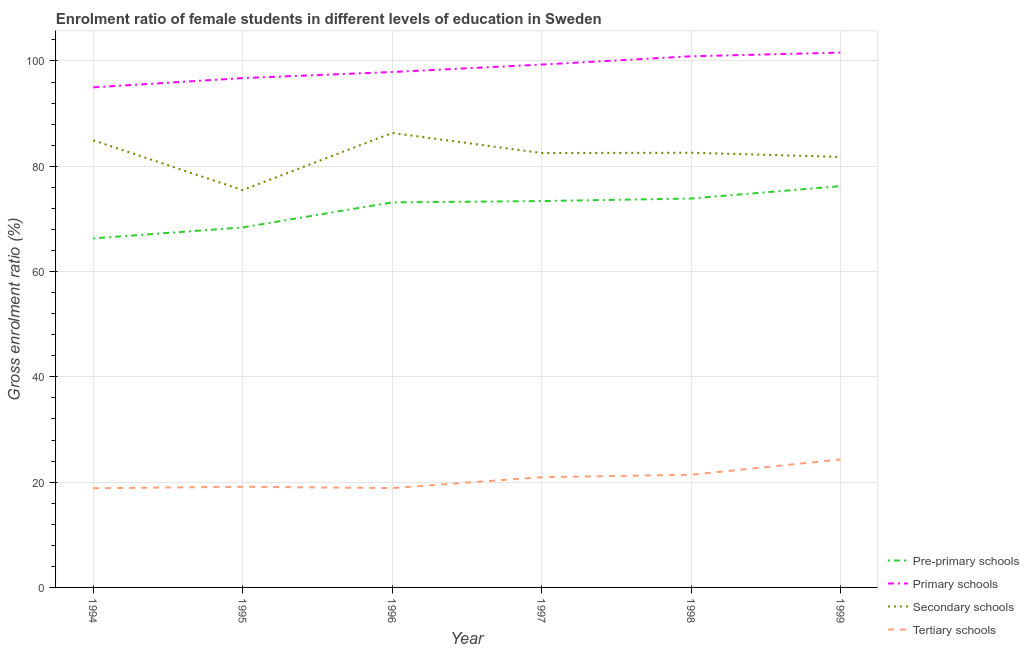What is the gross enrolment ratio(male) in primary schools in 1998?
Provide a short and direct response. 100.89. Across all years, what is the maximum gross enrolment ratio(male) in pre-primary schools?
Your answer should be compact. 76.23. Across all years, what is the minimum gross enrolment ratio(male) in tertiary schools?
Provide a short and direct response. 18.84. In which year was the gross enrolment ratio(male) in tertiary schools maximum?
Make the answer very short. 1999. What is the total gross enrolment ratio(male) in tertiary schools in the graph?
Provide a succinct answer. 123.48. What is the difference between the gross enrolment ratio(male) in primary schools in 1994 and that in 1997?
Your response must be concise. -4.33. What is the difference between the gross enrolment ratio(male) in primary schools in 1996 and the gross enrolment ratio(male) in tertiary schools in 1994?
Offer a very short reply. 79.06. What is the average gross enrolment ratio(male) in primary schools per year?
Offer a very short reply. 98.58. In the year 1999, what is the difference between the gross enrolment ratio(male) in primary schools and gross enrolment ratio(male) in tertiary schools?
Provide a short and direct response. 77.29. In how many years, is the gross enrolment ratio(male) in secondary schools greater than 68 %?
Your response must be concise. 6. What is the ratio of the gross enrolment ratio(male) in pre-primary schools in 1995 to that in 1996?
Ensure brevity in your answer.  0.93. Is the difference between the gross enrolment ratio(male) in tertiary schools in 1995 and 1998 greater than the difference between the gross enrolment ratio(male) in pre-primary schools in 1995 and 1998?
Your answer should be compact. Yes. What is the difference between the highest and the second highest gross enrolment ratio(male) in tertiary schools?
Offer a terse response. 2.9. What is the difference between the highest and the lowest gross enrolment ratio(male) in tertiary schools?
Your response must be concise. 5.46. In how many years, is the gross enrolment ratio(male) in secondary schools greater than the average gross enrolment ratio(male) in secondary schools taken over all years?
Offer a very short reply. 4. Is it the case that in every year, the sum of the gross enrolment ratio(male) in pre-primary schools and gross enrolment ratio(male) in primary schools is greater than the gross enrolment ratio(male) in secondary schools?
Your answer should be compact. Yes. Does the gross enrolment ratio(male) in primary schools monotonically increase over the years?
Your answer should be very brief. Yes. Is the gross enrolment ratio(male) in pre-primary schools strictly greater than the gross enrolment ratio(male) in secondary schools over the years?
Your answer should be compact. No. How many lines are there?
Give a very brief answer. 4. Are the values on the major ticks of Y-axis written in scientific E-notation?
Make the answer very short. No. Where does the legend appear in the graph?
Offer a terse response. Bottom right. What is the title of the graph?
Your answer should be compact. Enrolment ratio of female students in different levels of education in Sweden. Does "Manufacturing" appear as one of the legend labels in the graph?
Offer a terse response. No. What is the Gross enrolment ratio (%) in Pre-primary schools in 1994?
Your response must be concise. 66.3. What is the Gross enrolment ratio (%) in Primary schools in 1994?
Your answer should be compact. 94.99. What is the Gross enrolment ratio (%) of Secondary schools in 1994?
Keep it short and to the point. 84.93. What is the Gross enrolment ratio (%) of Tertiary schools in 1994?
Keep it short and to the point. 18.84. What is the Gross enrolment ratio (%) of Pre-primary schools in 1995?
Your response must be concise. 68.39. What is the Gross enrolment ratio (%) of Primary schools in 1995?
Offer a terse response. 96.75. What is the Gross enrolment ratio (%) in Secondary schools in 1995?
Make the answer very short. 75.47. What is the Gross enrolment ratio (%) in Tertiary schools in 1995?
Offer a very short reply. 19.12. What is the Gross enrolment ratio (%) in Pre-primary schools in 1996?
Offer a terse response. 73.14. What is the Gross enrolment ratio (%) in Primary schools in 1996?
Give a very brief answer. 97.91. What is the Gross enrolment ratio (%) in Secondary schools in 1996?
Provide a succinct answer. 86.33. What is the Gross enrolment ratio (%) of Tertiary schools in 1996?
Provide a short and direct response. 18.87. What is the Gross enrolment ratio (%) in Pre-primary schools in 1997?
Provide a succinct answer. 73.39. What is the Gross enrolment ratio (%) of Primary schools in 1997?
Your response must be concise. 99.32. What is the Gross enrolment ratio (%) of Secondary schools in 1997?
Offer a very short reply. 82.52. What is the Gross enrolment ratio (%) of Tertiary schools in 1997?
Offer a very short reply. 20.93. What is the Gross enrolment ratio (%) of Pre-primary schools in 1998?
Your response must be concise. 73.87. What is the Gross enrolment ratio (%) of Primary schools in 1998?
Make the answer very short. 100.89. What is the Gross enrolment ratio (%) in Secondary schools in 1998?
Make the answer very short. 82.57. What is the Gross enrolment ratio (%) of Tertiary schools in 1998?
Provide a succinct answer. 21.41. What is the Gross enrolment ratio (%) in Pre-primary schools in 1999?
Your answer should be compact. 76.23. What is the Gross enrolment ratio (%) in Primary schools in 1999?
Your response must be concise. 101.59. What is the Gross enrolment ratio (%) of Secondary schools in 1999?
Your answer should be very brief. 81.77. What is the Gross enrolment ratio (%) of Tertiary schools in 1999?
Your response must be concise. 24.31. Across all years, what is the maximum Gross enrolment ratio (%) in Pre-primary schools?
Make the answer very short. 76.23. Across all years, what is the maximum Gross enrolment ratio (%) of Primary schools?
Offer a very short reply. 101.59. Across all years, what is the maximum Gross enrolment ratio (%) of Secondary schools?
Offer a terse response. 86.33. Across all years, what is the maximum Gross enrolment ratio (%) of Tertiary schools?
Offer a terse response. 24.31. Across all years, what is the minimum Gross enrolment ratio (%) in Pre-primary schools?
Give a very brief answer. 66.3. Across all years, what is the minimum Gross enrolment ratio (%) of Primary schools?
Your response must be concise. 94.99. Across all years, what is the minimum Gross enrolment ratio (%) of Secondary schools?
Provide a succinct answer. 75.47. Across all years, what is the minimum Gross enrolment ratio (%) of Tertiary schools?
Your answer should be very brief. 18.84. What is the total Gross enrolment ratio (%) of Pre-primary schools in the graph?
Give a very brief answer. 431.32. What is the total Gross enrolment ratio (%) of Primary schools in the graph?
Keep it short and to the point. 591.45. What is the total Gross enrolment ratio (%) of Secondary schools in the graph?
Your response must be concise. 493.59. What is the total Gross enrolment ratio (%) in Tertiary schools in the graph?
Provide a succinct answer. 123.48. What is the difference between the Gross enrolment ratio (%) of Pre-primary schools in 1994 and that in 1995?
Give a very brief answer. -2.09. What is the difference between the Gross enrolment ratio (%) of Primary schools in 1994 and that in 1995?
Your answer should be compact. -1.76. What is the difference between the Gross enrolment ratio (%) in Secondary schools in 1994 and that in 1995?
Ensure brevity in your answer.  9.46. What is the difference between the Gross enrolment ratio (%) in Tertiary schools in 1994 and that in 1995?
Give a very brief answer. -0.28. What is the difference between the Gross enrolment ratio (%) in Pre-primary schools in 1994 and that in 1996?
Your answer should be compact. -6.84. What is the difference between the Gross enrolment ratio (%) in Primary schools in 1994 and that in 1996?
Offer a terse response. -2.92. What is the difference between the Gross enrolment ratio (%) in Secondary schools in 1994 and that in 1996?
Ensure brevity in your answer.  -1.4. What is the difference between the Gross enrolment ratio (%) in Tertiary schools in 1994 and that in 1996?
Offer a very short reply. -0.03. What is the difference between the Gross enrolment ratio (%) of Pre-primary schools in 1994 and that in 1997?
Ensure brevity in your answer.  -7.09. What is the difference between the Gross enrolment ratio (%) in Primary schools in 1994 and that in 1997?
Offer a terse response. -4.33. What is the difference between the Gross enrolment ratio (%) in Secondary schools in 1994 and that in 1997?
Give a very brief answer. 2.41. What is the difference between the Gross enrolment ratio (%) of Tertiary schools in 1994 and that in 1997?
Keep it short and to the point. -2.09. What is the difference between the Gross enrolment ratio (%) in Pre-primary schools in 1994 and that in 1998?
Your answer should be compact. -7.58. What is the difference between the Gross enrolment ratio (%) of Primary schools in 1994 and that in 1998?
Keep it short and to the point. -5.9. What is the difference between the Gross enrolment ratio (%) of Secondary schools in 1994 and that in 1998?
Your response must be concise. 2.36. What is the difference between the Gross enrolment ratio (%) of Tertiary schools in 1994 and that in 1998?
Offer a very short reply. -2.56. What is the difference between the Gross enrolment ratio (%) in Pre-primary schools in 1994 and that in 1999?
Make the answer very short. -9.94. What is the difference between the Gross enrolment ratio (%) of Primary schools in 1994 and that in 1999?
Your answer should be very brief. -6.6. What is the difference between the Gross enrolment ratio (%) of Secondary schools in 1994 and that in 1999?
Offer a very short reply. 3.15. What is the difference between the Gross enrolment ratio (%) in Tertiary schools in 1994 and that in 1999?
Make the answer very short. -5.46. What is the difference between the Gross enrolment ratio (%) in Pre-primary schools in 1995 and that in 1996?
Your answer should be very brief. -4.76. What is the difference between the Gross enrolment ratio (%) of Primary schools in 1995 and that in 1996?
Provide a short and direct response. -1.16. What is the difference between the Gross enrolment ratio (%) in Secondary schools in 1995 and that in 1996?
Give a very brief answer. -10.86. What is the difference between the Gross enrolment ratio (%) of Tertiary schools in 1995 and that in 1996?
Keep it short and to the point. 0.24. What is the difference between the Gross enrolment ratio (%) of Pre-primary schools in 1995 and that in 1997?
Keep it short and to the point. -5. What is the difference between the Gross enrolment ratio (%) of Primary schools in 1995 and that in 1997?
Offer a terse response. -2.57. What is the difference between the Gross enrolment ratio (%) in Secondary schools in 1995 and that in 1997?
Offer a very short reply. -7.04. What is the difference between the Gross enrolment ratio (%) in Tertiary schools in 1995 and that in 1997?
Offer a very short reply. -1.81. What is the difference between the Gross enrolment ratio (%) in Pre-primary schools in 1995 and that in 1998?
Make the answer very short. -5.49. What is the difference between the Gross enrolment ratio (%) in Primary schools in 1995 and that in 1998?
Provide a succinct answer. -4.14. What is the difference between the Gross enrolment ratio (%) of Secondary schools in 1995 and that in 1998?
Your response must be concise. -7.1. What is the difference between the Gross enrolment ratio (%) of Tertiary schools in 1995 and that in 1998?
Give a very brief answer. -2.29. What is the difference between the Gross enrolment ratio (%) of Pre-primary schools in 1995 and that in 1999?
Your answer should be very brief. -7.85. What is the difference between the Gross enrolment ratio (%) in Primary schools in 1995 and that in 1999?
Provide a succinct answer. -4.84. What is the difference between the Gross enrolment ratio (%) in Secondary schools in 1995 and that in 1999?
Ensure brevity in your answer.  -6.3. What is the difference between the Gross enrolment ratio (%) in Tertiary schools in 1995 and that in 1999?
Ensure brevity in your answer.  -5.19. What is the difference between the Gross enrolment ratio (%) in Pre-primary schools in 1996 and that in 1997?
Ensure brevity in your answer.  -0.25. What is the difference between the Gross enrolment ratio (%) of Primary schools in 1996 and that in 1997?
Your answer should be very brief. -1.41. What is the difference between the Gross enrolment ratio (%) of Secondary schools in 1996 and that in 1997?
Your response must be concise. 3.81. What is the difference between the Gross enrolment ratio (%) in Tertiary schools in 1996 and that in 1997?
Ensure brevity in your answer.  -2.06. What is the difference between the Gross enrolment ratio (%) of Pre-primary schools in 1996 and that in 1998?
Your response must be concise. -0.73. What is the difference between the Gross enrolment ratio (%) in Primary schools in 1996 and that in 1998?
Keep it short and to the point. -2.99. What is the difference between the Gross enrolment ratio (%) of Secondary schools in 1996 and that in 1998?
Your response must be concise. 3.76. What is the difference between the Gross enrolment ratio (%) of Tertiary schools in 1996 and that in 1998?
Your answer should be very brief. -2.53. What is the difference between the Gross enrolment ratio (%) in Pre-primary schools in 1996 and that in 1999?
Provide a short and direct response. -3.09. What is the difference between the Gross enrolment ratio (%) of Primary schools in 1996 and that in 1999?
Your response must be concise. -3.69. What is the difference between the Gross enrolment ratio (%) in Secondary schools in 1996 and that in 1999?
Provide a short and direct response. 4.55. What is the difference between the Gross enrolment ratio (%) in Tertiary schools in 1996 and that in 1999?
Offer a terse response. -5.43. What is the difference between the Gross enrolment ratio (%) of Pre-primary schools in 1997 and that in 1998?
Offer a very short reply. -0.48. What is the difference between the Gross enrolment ratio (%) of Primary schools in 1997 and that in 1998?
Give a very brief answer. -1.57. What is the difference between the Gross enrolment ratio (%) in Secondary schools in 1997 and that in 1998?
Offer a terse response. -0.06. What is the difference between the Gross enrolment ratio (%) in Tertiary schools in 1997 and that in 1998?
Give a very brief answer. -0.47. What is the difference between the Gross enrolment ratio (%) in Pre-primary schools in 1997 and that in 1999?
Provide a short and direct response. -2.84. What is the difference between the Gross enrolment ratio (%) of Primary schools in 1997 and that in 1999?
Keep it short and to the point. -2.27. What is the difference between the Gross enrolment ratio (%) in Secondary schools in 1997 and that in 1999?
Provide a short and direct response. 0.74. What is the difference between the Gross enrolment ratio (%) of Tertiary schools in 1997 and that in 1999?
Give a very brief answer. -3.37. What is the difference between the Gross enrolment ratio (%) of Pre-primary schools in 1998 and that in 1999?
Your answer should be compact. -2.36. What is the difference between the Gross enrolment ratio (%) in Primary schools in 1998 and that in 1999?
Your response must be concise. -0.7. What is the difference between the Gross enrolment ratio (%) of Secondary schools in 1998 and that in 1999?
Your response must be concise. 0.8. What is the difference between the Gross enrolment ratio (%) in Tertiary schools in 1998 and that in 1999?
Provide a succinct answer. -2.9. What is the difference between the Gross enrolment ratio (%) in Pre-primary schools in 1994 and the Gross enrolment ratio (%) in Primary schools in 1995?
Keep it short and to the point. -30.45. What is the difference between the Gross enrolment ratio (%) in Pre-primary schools in 1994 and the Gross enrolment ratio (%) in Secondary schools in 1995?
Offer a terse response. -9.18. What is the difference between the Gross enrolment ratio (%) in Pre-primary schools in 1994 and the Gross enrolment ratio (%) in Tertiary schools in 1995?
Offer a very short reply. 47.18. What is the difference between the Gross enrolment ratio (%) of Primary schools in 1994 and the Gross enrolment ratio (%) of Secondary schools in 1995?
Your response must be concise. 19.52. What is the difference between the Gross enrolment ratio (%) in Primary schools in 1994 and the Gross enrolment ratio (%) in Tertiary schools in 1995?
Keep it short and to the point. 75.87. What is the difference between the Gross enrolment ratio (%) in Secondary schools in 1994 and the Gross enrolment ratio (%) in Tertiary schools in 1995?
Offer a very short reply. 65.81. What is the difference between the Gross enrolment ratio (%) of Pre-primary schools in 1994 and the Gross enrolment ratio (%) of Primary schools in 1996?
Your answer should be very brief. -31.61. What is the difference between the Gross enrolment ratio (%) of Pre-primary schools in 1994 and the Gross enrolment ratio (%) of Secondary schools in 1996?
Keep it short and to the point. -20.03. What is the difference between the Gross enrolment ratio (%) in Pre-primary schools in 1994 and the Gross enrolment ratio (%) in Tertiary schools in 1996?
Your response must be concise. 47.42. What is the difference between the Gross enrolment ratio (%) in Primary schools in 1994 and the Gross enrolment ratio (%) in Secondary schools in 1996?
Offer a terse response. 8.66. What is the difference between the Gross enrolment ratio (%) of Primary schools in 1994 and the Gross enrolment ratio (%) of Tertiary schools in 1996?
Your answer should be very brief. 76.12. What is the difference between the Gross enrolment ratio (%) in Secondary schools in 1994 and the Gross enrolment ratio (%) in Tertiary schools in 1996?
Give a very brief answer. 66.05. What is the difference between the Gross enrolment ratio (%) of Pre-primary schools in 1994 and the Gross enrolment ratio (%) of Primary schools in 1997?
Ensure brevity in your answer.  -33.02. What is the difference between the Gross enrolment ratio (%) of Pre-primary schools in 1994 and the Gross enrolment ratio (%) of Secondary schools in 1997?
Your answer should be very brief. -16.22. What is the difference between the Gross enrolment ratio (%) in Pre-primary schools in 1994 and the Gross enrolment ratio (%) in Tertiary schools in 1997?
Your answer should be very brief. 45.36. What is the difference between the Gross enrolment ratio (%) in Primary schools in 1994 and the Gross enrolment ratio (%) in Secondary schools in 1997?
Your response must be concise. 12.47. What is the difference between the Gross enrolment ratio (%) in Primary schools in 1994 and the Gross enrolment ratio (%) in Tertiary schools in 1997?
Give a very brief answer. 74.06. What is the difference between the Gross enrolment ratio (%) of Secondary schools in 1994 and the Gross enrolment ratio (%) of Tertiary schools in 1997?
Provide a short and direct response. 64. What is the difference between the Gross enrolment ratio (%) in Pre-primary schools in 1994 and the Gross enrolment ratio (%) in Primary schools in 1998?
Offer a very short reply. -34.6. What is the difference between the Gross enrolment ratio (%) in Pre-primary schools in 1994 and the Gross enrolment ratio (%) in Secondary schools in 1998?
Your answer should be very brief. -16.28. What is the difference between the Gross enrolment ratio (%) in Pre-primary schools in 1994 and the Gross enrolment ratio (%) in Tertiary schools in 1998?
Your answer should be very brief. 44.89. What is the difference between the Gross enrolment ratio (%) of Primary schools in 1994 and the Gross enrolment ratio (%) of Secondary schools in 1998?
Make the answer very short. 12.42. What is the difference between the Gross enrolment ratio (%) in Primary schools in 1994 and the Gross enrolment ratio (%) in Tertiary schools in 1998?
Your answer should be compact. 73.59. What is the difference between the Gross enrolment ratio (%) of Secondary schools in 1994 and the Gross enrolment ratio (%) of Tertiary schools in 1998?
Make the answer very short. 63.52. What is the difference between the Gross enrolment ratio (%) in Pre-primary schools in 1994 and the Gross enrolment ratio (%) in Primary schools in 1999?
Offer a very short reply. -35.3. What is the difference between the Gross enrolment ratio (%) in Pre-primary schools in 1994 and the Gross enrolment ratio (%) in Secondary schools in 1999?
Offer a terse response. -15.48. What is the difference between the Gross enrolment ratio (%) in Pre-primary schools in 1994 and the Gross enrolment ratio (%) in Tertiary schools in 1999?
Provide a succinct answer. 41.99. What is the difference between the Gross enrolment ratio (%) of Primary schools in 1994 and the Gross enrolment ratio (%) of Secondary schools in 1999?
Offer a very short reply. 13.22. What is the difference between the Gross enrolment ratio (%) of Primary schools in 1994 and the Gross enrolment ratio (%) of Tertiary schools in 1999?
Give a very brief answer. 70.68. What is the difference between the Gross enrolment ratio (%) in Secondary schools in 1994 and the Gross enrolment ratio (%) in Tertiary schools in 1999?
Ensure brevity in your answer.  60.62. What is the difference between the Gross enrolment ratio (%) in Pre-primary schools in 1995 and the Gross enrolment ratio (%) in Primary schools in 1996?
Offer a terse response. -29.52. What is the difference between the Gross enrolment ratio (%) of Pre-primary schools in 1995 and the Gross enrolment ratio (%) of Secondary schools in 1996?
Ensure brevity in your answer.  -17.94. What is the difference between the Gross enrolment ratio (%) in Pre-primary schools in 1995 and the Gross enrolment ratio (%) in Tertiary schools in 1996?
Your response must be concise. 49.51. What is the difference between the Gross enrolment ratio (%) in Primary schools in 1995 and the Gross enrolment ratio (%) in Secondary schools in 1996?
Offer a terse response. 10.42. What is the difference between the Gross enrolment ratio (%) in Primary schools in 1995 and the Gross enrolment ratio (%) in Tertiary schools in 1996?
Make the answer very short. 77.87. What is the difference between the Gross enrolment ratio (%) of Secondary schools in 1995 and the Gross enrolment ratio (%) of Tertiary schools in 1996?
Offer a very short reply. 56.6. What is the difference between the Gross enrolment ratio (%) of Pre-primary schools in 1995 and the Gross enrolment ratio (%) of Primary schools in 1997?
Make the answer very short. -30.93. What is the difference between the Gross enrolment ratio (%) in Pre-primary schools in 1995 and the Gross enrolment ratio (%) in Secondary schools in 1997?
Keep it short and to the point. -14.13. What is the difference between the Gross enrolment ratio (%) of Pre-primary schools in 1995 and the Gross enrolment ratio (%) of Tertiary schools in 1997?
Your response must be concise. 47.45. What is the difference between the Gross enrolment ratio (%) in Primary schools in 1995 and the Gross enrolment ratio (%) in Secondary schools in 1997?
Provide a short and direct response. 14.23. What is the difference between the Gross enrolment ratio (%) in Primary schools in 1995 and the Gross enrolment ratio (%) in Tertiary schools in 1997?
Give a very brief answer. 75.82. What is the difference between the Gross enrolment ratio (%) of Secondary schools in 1995 and the Gross enrolment ratio (%) of Tertiary schools in 1997?
Provide a succinct answer. 54.54. What is the difference between the Gross enrolment ratio (%) in Pre-primary schools in 1995 and the Gross enrolment ratio (%) in Primary schools in 1998?
Offer a very short reply. -32.51. What is the difference between the Gross enrolment ratio (%) of Pre-primary schools in 1995 and the Gross enrolment ratio (%) of Secondary schools in 1998?
Provide a succinct answer. -14.19. What is the difference between the Gross enrolment ratio (%) of Pre-primary schools in 1995 and the Gross enrolment ratio (%) of Tertiary schools in 1998?
Give a very brief answer. 46.98. What is the difference between the Gross enrolment ratio (%) in Primary schools in 1995 and the Gross enrolment ratio (%) in Secondary schools in 1998?
Offer a terse response. 14.18. What is the difference between the Gross enrolment ratio (%) in Primary schools in 1995 and the Gross enrolment ratio (%) in Tertiary schools in 1998?
Your response must be concise. 75.34. What is the difference between the Gross enrolment ratio (%) of Secondary schools in 1995 and the Gross enrolment ratio (%) of Tertiary schools in 1998?
Offer a very short reply. 54.07. What is the difference between the Gross enrolment ratio (%) in Pre-primary schools in 1995 and the Gross enrolment ratio (%) in Primary schools in 1999?
Your answer should be very brief. -33.21. What is the difference between the Gross enrolment ratio (%) in Pre-primary schools in 1995 and the Gross enrolment ratio (%) in Secondary schools in 1999?
Keep it short and to the point. -13.39. What is the difference between the Gross enrolment ratio (%) in Pre-primary schools in 1995 and the Gross enrolment ratio (%) in Tertiary schools in 1999?
Offer a terse response. 44.08. What is the difference between the Gross enrolment ratio (%) of Primary schools in 1995 and the Gross enrolment ratio (%) of Secondary schools in 1999?
Ensure brevity in your answer.  14.97. What is the difference between the Gross enrolment ratio (%) of Primary schools in 1995 and the Gross enrolment ratio (%) of Tertiary schools in 1999?
Offer a terse response. 72.44. What is the difference between the Gross enrolment ratio (%) of Secondary schools in 1995 and the Gross enrolment ratio (%) of Tertiary schools in 1999?
Ensure brevity in your answer.  51.17. What is the difference between the Gross enrolment ratio (%) of Pre-primary schools in 1996 and the Gross enrolment ratio (%) of Primary schools in 1997?
Make the answer very short. -26.18. What is the difference between the Gross enrolment ratio (%) in Pre-primary schools in 1996 and the Gross enrolment ratio (%) in Secondary schools in 1997?
Offer a terse response. -9.38. What is the difference between the Gross enrolment ratio (%) of Pre-primary schools in 1996 and the Gross enrolment ratio (%) of Tertiary schools in 1997?
Make the answer very short. 52.21. What is the difference between the Gross enrolment ratio (%) of Primary schools in 1996 and the Gross enrolment ratio (%) of Secondary schools in 1997?
Keep it short and to the point. 15.39. What is the difference between the Gross enrolment ratio (%) of Primary schools in 1996 and the Gross enrolment ratio (%) of Tertiary schools in 1997?
Ensure brevity in your answer.  76.97. What is the difference between the Gross enrolment ratio (%) of Secondary schools in 1996 and the Gross enrolment ratio (%) of Tertiary schools in 1997?
Your response must be concise. 65.39. What is the difference between the Gross enrolment ratio (%) of Pre-primary schools in 1996 and the Gross enrolment ratio (%) of Primary schools in 1998?
Give a very brief answer. -27.75. What is the difference between the Gross enrolment ratio (%) of Pre-primary schools in 1996 and the Gross enrolment ratio (%) of Secondary schools in 1998?
Your answer should be very brief. -9.43. What is the difference between the Gross enrolment ratio (%) of Pre-primary schools in 1996 and the Gross enrolment ratio (%) of Tertiary schools in 1998?
Ensure brevity in your answer.  51.74. What is the difference between the Gross enrolment ratio (%) of Primary schools in 1996 and the Gross enrolment ratio (%) of Secondary schools in 1998?
Offer a very short reply. 15.33. What is the difference between the Gross enrolment ratio (%) of Primary schools in 1996 and the Gross enrolment ratio (%) of Tertiary schools in 1998?
Offer a terse response. 76.5. What is the difference between the Gross enrolment ratio (%) in Secondary schools in 1996 and the Gross enrolment ratio (%) in Tertiary schools in 1998?
Your answer should be compact. 64.92. What is the difference between the Gross enrolment ratio (%) of Pre-primary schools in 1996 and the Gross enrolment ratio (%) of Primary schools in 1999?
Provide a succinct answer. -28.45. What is the difference between the Gross enrolment ratio (%) in Pre-primary schools in 1996 and the Gross enrolment ratio (%) in Secondary schools in 1999?
Keep it short and to the point. -8.63. What is the difference between the Gross enrolment ratio (%) of Pre-primary schools in 1996 and the Gross enrolment ratio (%) of Tertiary schools in 1999?
Provide a short and direct response. 48.83. What is the difference between the Gross enrolment ratio (%) of Primary schools in 1996 and the Gross enrolment ratio (%) of Secondary schools in 1999?
Give a very brief answer. 16.13. What is the difference between the Gross enrolment ratio (%) in Primary schools in 1996 and the Gross enrolment ratio (%) in Tertiary schools in 1999?
Your answer should be compact. 73.6. What is the difference between the Gross enrolment ratio (%) of Secondary schools in 1996 and the Gross enrolment ratio (%) of Tertiary schools in 1999?
Offer a very short reply. 62.02. What is the difference between the Gross enrolment ratio (%) of Pre-primary schools in 1997 and the Gross enrolment ratio (%) of Primary schools in 1998?
Offer a terse response. -27.5. What is the difference between the Gross enrolment ratio (%) of Pre-primary schools in 1997 and the Gross enrolment ratio (%) of Secondary schools in 1998?
Your answer should be compact. -9.18. What is the difference between the Gross enrolment ratio (%) in Pre-primary schools in 1997 and the Gross enrolment ratio (%) in Tertiary schools in 1998?
Your answer should be very brief. 51.99. What is the difference between the Gross enrolment ratio (%) of Primary schools in 1997 and the Gross enrolment ratio (%) of Secondary schools in 1998?
Offer a very short reply. 16.75. What is the difference between the Gross enrolment ratio (%) in Primary schools in 1997 and the Gross enrolment ratio (%) in Tertiary schools in 1998?
Your answer should be compact. 77.91. What is the difference between the Gross enrolment ratio (%) in Secondary schools in 1997 and the Gross enrolment ratio (%) in Tertiary schools in 1998?
Your answer should be compact. 61.11. What is the difference between the Gross enrolment ratio (%) of Pre-primary schools in 1997 and the Gross enrolment ratio (%) of Primary schools in 1999?
Ensure brevity in your answer.  -28.2. What is the difference between the Gross enrolment ratio (%) in Pre-primary schools in 1997 and the Gross enrolment ratio (%) in Secondary schools in 1999?
Provide a succinct answer. -8.38. What is the difference between the Gross enrolment ratio (%) of Pre-primary schools in 1997 and the Gross enrolment ratio (%) of Tertiary schools in 1999?
Keep it short and to the point. 49.08. What is the difference between the Gross enrolment ratio (%) in Primary schools in 1997 and the Gross enrolment ratio (%) in Secondary schools in 1999?
Offer a very short reply. 17.54. What is the difference between the Gross enrolment ratio (%) of Primary schools in 1997 and the Gross enrolment ratio (%) of Tertiary schools in 1999?
Your response must be concise. 75.01. What is the difference between the Gross enrolment ratio (%) of Secondary schools in 1997 and the Gross enrolment ratio (%) of Tertiary schools in 1999?
Keep it short and to the point. 58.21. What is the difference between the Gross enrolment ratio (%) in Pre-primary schools in 1998 and the Gross enrolment ratio (%) in Primary schools in 1999?
Ensure brevity in your answer.  -27.72. What is the difference between the Gross enrolment ratio (%) in Pre-primary schools in 1998 and the Gross enrolment ratio (%) in Secondary schools in 1999?
Make the answer very short. -7.9. What is the difference between the Gross enrolment ratio (%) in Pre-primary schools in 1998 and the Gross enrolment ratio (%) in Tertiary schools in 1999?
Ensure brevity in your answer.  49.57. What is the difference between the Gross enrolment ratio (%) of Primary schools in 1998 and the Gross enrolment ratio (%) of Secondary schools in 1999?
Make the answer very short. 19.12. What is the difference between the Gross enrolment ratio (%) of Primary schools in 1998 and the Gross enrolment ratio (%) of Tertiary schools in 1999?
Give a very brief answer. 76.59. What is the difference between the Gross enrolment ratio (%) of Secondary schools in 1998 and the Gross enrolment ratio (%) of Tertiary schools in 1999?
Ensure brevity in your answer.  58.27. What is the average Gross enrolment ratio (%) in Pre-primary schools per year?
Offer a terse response. 71.89. What is the average Gross enrolment ratio (%) of Primary schools per year?
Make the answer very short. 98.58. What is the average Gross enrolment ratio (%) of Secondary schools per year?
Your response must be concise. 82.27. What is the average Gross enrolment ratio (%) in Tertiary schools per year?
Provide a succinct answer. 20.58. In the year 1994, what is the difference between the Gross enrolment ratio (%) in Pre-primary schools and Gross enrolment ratio (%) in Primary schools?
Offer a very short reply. -28.69. In the year 1994, what is the difference between the Gross enrolment ratio (%) in Pre-primary schools and Gross enrolment ratio (%) in Secondary schools?
Your answer should be compact. -18.63. In the year 1994, what is the difference between the Gross enrolment ratio (%) in Pre-primary schools and Gross enrolment ratio (%) in Tertiary schools?
Provide a succinct answer. 47.45. In the year 1994, what is the difference between the Gross enrolment ratio (%) of Primary schools and Gross enrolment ratio (%) of Secondary schools?
Ensure brevity in your answer.  10.06. In the year 1994, what is the difference between the Gross enrolment ratio (%) in Primary schools and Gross enrolment ratio (%) in Tertiary schools?
Offer a very short reply. 76.15. In the year 1994, what is the difference between the Gross enrolment ratio (%) of Secondary schools and Gross enrolment ratio (%) of Tertiary schools?
Give a very brief answer. 66.09. In the year 1995, what is the difference between the Gross enrolment ratio (%) in Pre-primary schools and Gross enrolment ratio (%) in Primary schools?
Your response must be concise. -28.36. In the year 1995, what is the difference between the Gross enrolment ratio (%) of Pre-primary schools and Gross enrolment ratio (%) of Secondary schools?
Your answer should be very brief. -7.09. In the year 1995, what is the difference between the Gross enrolment ratio (%) of Pre-primary schools and Gross enrolment ratio (%) of Tertiary schools?
Offer a terse response. 49.27. In the year 1995, what is the difference between the Gross enrolment ratio (%) in Primary schools and Gross enrolment ratio (%) in Secondary schools?
Provide a short and direct response. 21.28. In the year 1995, what is the difference between the Gross enrolment ratio (%) of Primary schools and Gross enrolment ratio (%) of Tertiary schools?
Offer a very short reply. 77.63. In the year 1995, what is the difference between the Gross enrolment ratio (%) of Secondary schools and Gross enrolment ratio (%) of Tertiary schools?
Offer a terse response. 56.35. In the year 1996, what is the difference between the Gross enrolment ratio (%) in Pre-primary schools and Gross enrolment ratio (%) in Primary schools?
Offer a very short reply. -24.77. In the year 1996, what is the difference between the Gross enrolment ratio (%) in Pre-primary schools and Gross enrolment ratio (%) in Secondary schools?
Provide a succinct answer. -13.19. In the year 1996, what is the difference between the Gross enrolment ratio (%) in Pre-primary schools and Gross enrolment ratio (%) in Tertiary schools?
Make the answer very short. 54.27. In the year 1996, what is the difference between the Gross enrolment ratio (%) in Primary schools and Gross enrolment ratio (%) in Secondary schools?
Give a very brief answer. 11.58. In the year 1996, what is the difference between the Gross enrolment ratio (%) of Primary schools and Gross enrolment ratio (%) of Tertiary schools?
Ensure brevity in your answer.  79.03. In the year 1996, what is the difference between the Gross enrolment ratio (%) of Secondary schools and Gross enrolment ratio (%) of Tertiary schools?
Provide a succinct answer. 67.45. In the year 1997, what is the difference between the Gross enrolment ratio (%) of Pre-primary schools and Gross enrolment ratio (%) of Primary schools?
Your answer should be very brief. -25.93. In the year 1997, what is the difference between the Gross enrolment ratio (%) in Pre-primary schools and Gross enrolment ratio (%) in Secondary schools?
Your response must be concise. -9.13. In the year 1997, what is the difference between the Gross enrolment ratio (%) in Pre-primary schools and Gross enrolment ratio (%) in Tertiary schools?
Give a very brief answer. 52.46. In the year 1997, what is the difference between the Gross enrolment ratio (%) in Primary schools and Gross enrolment ratio (%) in Secondary schools?
Keep it short and to the point. 16.8. In the year 1997, what is the difference between the Gross enrolment ratio (%) of Primary schools and Gross enrolment ratio (%) of Tertiary schools?
Provide a succinct answer. 78.39. In the year 1997, what is the difference between the Gross enrolment ratio (%) of Secondary schools and Gross enrolment ratio (%) of Tertiary schools?
Keep it short and to the point. 61.58. In the year 1998, what is the difference between the Gross enrolment ratio (%) of Pre-primary schools and Gross enrolment ratio (%) of Primary schools?
Ensure brevity in your answer.  -27.02. In the year 1998, what is the difference between the Gross enrolment ratio (%) of Pre-primary schools and Gross enrolment ratio (%) of Secondary schools?
Provide a succinct answer. -8.7. In the year 1998, what is the difference between the Gross enrolment ratio (%) of Pre-primary schools and Gross enrolment ratio (%) of Tertiary schools?
Make the answer very short. 52.47. In the year 1998, what is the difference between the Gross enrolment ratio (%) in Primary schools and Gross enrolment ratio (%) in Secondary schools?
Your answer should be compact. 18.32. In the year 1998, what is the difference between the Gross enrolment ratio (%) in Primary schools and Gross enrolment ratio (%) in Tertiary schools?
Keep it short and to the point. 79.49. In the year 1998, what is the difference between the Gross enrolment ratio (%) in Secondary schools and Gross enrolment ratio (%) in Tertiary schools?
Ensure brevity in your answer.  61.17. In the year 1999, what is the difference between the Gross enrolment ratio (%) in Pre-primary schools and Gross enrolment ratio (%) in Primary schools?
Your answer should be very brief. -25.36. In the year 1999, what is the difference between the Gross enrolment ratio (%) of Pre-primary schools and Gross enrolment ratio (%) of Secondary schools?
Keep it short and to the point. -5.54. In the year 1999, what is the difference between the Gross enrolment ratio (%) of Pre-primary schools and Gross enrolment ratio (%) of Tertiary schools?
Keep it short and to the point. 51.93. In the year 1999, what is the difference between the Gross enrolment ratio (%) in Primary schools and Gross enrolment ratio (%) in Secondary schools?
Provide a short and direct response. 19.82. In the year 1999, what is the difference between the Gross enrolment ratio (%) in Primary schools and Gross enrolment ratio (%) in Tertiary schools?
Ensure brevity in your answer.  77.29. In the year 1999, what is the difference between the Gross enrolment ratio (%) in Secondary schools and Gross enrolment ratio (%) in Tertiary schools?
Provide a short and direct response. 57.47. What is the ratio of the Gross enrolment ratio (%) in Pre-primary schools in 1994 to that in 1995?
Keep it short and to the point. 0.97. What is the ratio of the Gross enrolment ratio (%) in Primary schools in 1994 to that in 1995?
Keep it short and to the point. 0.98. What is the ratio of the Gross enrolment ratio (%) of Secondary schools in 1994 to that in 1995?
Keep it short and to the point. 1.13. What is the ratio of the Gross enrolment ratio (%) of Tertiary schools in 1994 to that in 1995?
Offer a very short reply. 0.99. What is the ratio of the Gross enrolment ratio (%) of Pre-primary schools in 1994 to that in 1996?
Your response must be concise. 0.91. What is the ratio of the Gross enrolment ratio (%) in Primary schools in 1994 to that in 1996?
Keep it short and to the point. 0.97. What is the ratio of the Gross enrolment ratio (%) in Secondary schools in 1994 to that in 1996?
Provide a succinct answer. 0.98. What is the ratio of the Gross enrolment ratio (%) of Tertiary schools in 1994 to that in 1996?
Your answer should be compact. 1. What is the ratio of the Gross enrolment ratio (%) of Pre-primary schools in 1994 to that in 1997?
Provide a succinct answer. 0.9. What is the ratio of the Gross enrolment ratio (%) of Primary schools in 1994 to that in 1997?
Provide a short and direct response. 0.96. What is the ratio of the Gross enrolment ratio (%) in Secondary schools in 1994 to that in 1997?
Offer a very short reply. 1.03. What is the ratio of the Gross enrolment ratio (%) in Tertiary schools in 1994 to that in 1997?
Make the answer very short. 0.9. What is the ratio of the Gross enrolment ratio (%) of Pre-primary schools in 1994 to that in 1998?
Ensure brevity in your answer.  0.9. What is the ratio of the Gross enrolment ratio (%) of Primary schools in 1994 to that in 1998?
Give a very brief answer. 0.94. What is the ratio of the Gross enrolment ratio (%) of Secondary schools in 1994 to that in 1998?
Your answer should be compact. 1.03. What is the ratio of the Gross enrolment ratio (%) of Tertiary schools in 1994 to that in 1998?
Your answer should be compact. 0.88. What is the ratio of the Gross enrolment ratio (%) in Pre-primary schools in 1994 to that in 1999?
Keep it short and to the point. 0.87. What is the ratio of the Gross enrolment ratio (%) in Primary schools in 1994 to that in 1999?
Offer a terse response. 0.94. What is the ratio of the Gross enrolment ratio (%) in Secondary schools in 1994 to that in 1999?
Provide a short and direct response. 1.04. What is the ratio of the Gross enrolment ratio (%) of Tertiary schools in 1994 to that in 1999?
Offer a very short reply. 0.78. What is the ratio of the Gross enrolment ratio (%) in Pre-primary schools in 1995 to that in 1996?
Provide a short and direct response. 0.94. What is the ratio of the Gross enrolment ratio (%) of Primary schools in 1995 to that in 1996?
Offer a terse response. 0.99. What is the ratio of the Gross enrolment ratio (%) of Secondary schools in 1995 to that in 1996?
Make the answer very short. 0.87. What is the ratio of the Gross enrolment ratio (%) in Tertiary schools in 1995 to that in 1996?
Offer a terse response. 1.01. What is the ratio of the Gross enrolment ratio (%) in Pre-primary schools in 1995 to that in 1997?
Keep it short and to the point. 0.93. What is the ratio of the Gross enrolment ratio (%) of Primary schools in 1995 to that in 1997?
Offer a terse response. 0.97. What is the ratio of the Gross enrolment ratio (%) in Secondary schools in 1995 to that in 1997?
Offer a terse response. 0.91. What is the ratio of the Gross enrolment ratio (%) in Tertiary schools in 1995 to that in 1997?
Keep it short and to the point. 0.91. What is the ratio of the Gross enrolment ratio (%) of Pre-primary schools in 1995 to that in 1998?
Ensure brevity in your answer.  0.93. What is the ratio of the Gross enrolment ratio (%) of Primary schools in 1995 to that in 1998?
Your answer should be compact. 0.96. What is the ratio of the Gross enrolment ratio (%) of Secondary schools in 1995 to that in 1998?
Your response must be concise. 0.91. What is the ratio of the Gross enrolment ratio (%) of Tertiary schools in 1995 to that in 1998?
Provide a short and direct response. 0.89. What is the ratio of the Gross enrolment ratio (%) in Pre-primary schools in 1995 to that in 1999?
Your response must be concise. 0.9. What is the ratio of the Gross enrolment ratio (%) of Primary schools in 1995 to that in 1999?
Your answer should be very brief. 0.95. What is the ratio of the Gross enrolment ratio (%) of Secondary schools in 1995 to that in 1999?
Keep it short and to the point. 0.92. What is the ratio of the Gross enrolment ratio (%) of Tertiary schools in 1995 to that in 1999?
Provide a succinct answer. 0.79. What is the ratio of the Gross enrolment ratio (%) in Pre-primary schools in 1996 to that in 1997?
Offer a terse response. 1. What is the ratio of the Gross enrolment ratio (%) in Primary schools in 1996 to that in 1997?
Offer a terse response. 0.99. What is the ratio of the Gross enrolment ratio (%) in Secondary schools in 1996 to that in 1997?
Ensure brevity in your answer.  1.05. What is the ratio of the Gross enrolment ratio (%) of Tertiary schools in 1996 to that in 1997?
Give a very brief answer. 0.9. What is the ratio of the Gross enrolment ratio (%) in Primary schools in 1996 to that in 1998?
Ensure brevity in your answer.  0.97. What is the ratio of the Gross enrolment ratio (%) of Secondary schools in 1996 to that in 1998?
Provide a short and direct response. 1.05. What is the ratio of the Gross enrolment ratio (%) in Tertiary schools in 1996 to that in 1998?
Give a very brief answer. 0.88. What is the ratio of the Gross enrolment ratio (%) of Pre-primary schools in 1996 to that in 1999?
Make the answer very short. 0.96. What is the ratio of the Gross enrolment ratio (%) of Primary schools in 1996 to that in 1999?
Offer a very short reply. 0.96. What is the ratio of the Gross enrolment ratio (%) of Secondary schools in 1996 to that in 1999?
Make the answer very short. 1.06. What is the ratio of the Gross enrolment ratio (%) of Tertiary schools in 1996 to that in 1999?
Keep it short and to the point. 0.78. What is the ratio of the Gross enrolment ratio (%) of Primary schools in 1997 to that in 1998?
Provide a short and direct response. 0.98. What is the ratio of the Gross enrolment ratio (%) of Secondary schools in 1997 to that in 1998?
Ensure brevity in your answer.  1. What is the ratio of the Gross enrolment ratio (%) in Tertiary schools in 1997 to that in 1998?
Your answer should be compact. 0.98. What is the ratio of the Gross enrolment ratio (%) of Pre-primary schools in 1997 to that in 1999?
Provide a succinct answer. 0.96. What is the ratio of the Gross enrolment ratio (%) of Primary schools in 1997 to that in 1999?
Provide a short and direct response. 0.98. What is the ratio of the Gross enrolment ratio (%) in Secondary schools in 1997 to that in 1999?
Give a very brief answer. 1.01. What is the ratio of the Gross enrolment ratio (%) in Tertiary schools in 1997 to that in 1999?
Your answer should be very brief. 0.86. What is the ratio of the Gross enrolment ratio (%) in Pre-primary schools in 1998 to that in 1999?
Ensure brevity in your answer.  0.97. What is the ratio of the Gross enrolment ratio (%) in Primary schools in 1998 to that in 1999?
Provide a succinct answer. 0.99. What is the ratio of the Gross enrolment ratio (%) of Secondary schools in 1998 to that in 1999?
Provide a succinct answer. 1.01. What is the ratio of the Gross enrolment ratio (%) of Tertiary schools in 1998 to that in 1999?
Offer a terse response. 0.88. What is the difference between the highest and the second highest Gross enrolment ratio (%) of Pre-primary schools?
Your answer should be compact. 2.36. What is the difference between the highest and the second highest Gross enrolment ratio (%) of Primary schools?
Your answer should be compact. 0.7. What is the difference between the highest and the second highest Gross enrolment ratio (%) in Secondary schools?
Ensure brevity in your answer.  1.4. What is the difference between the highest and the second highest Gross enrolment ratio (%) of Tertiary schools?
Provide a short and direct response. 2.9. What is the difference between the highest and the lowest Gross enrolment ratio (%) of Pre-primary schools?
Offer a very short reply. 9.94. What is the difference between the highest and the lowest Gross enrolment ratio (%) in Primary schools?
Ensure brevity in your answer.  6.6. What is the difference between the highest and the lowest Gross enrolment ratio (%) in Secondary schools?
Give a very brief answer. 10.86. What is the difference between the highest and the lowest Gross enrolment ratio (%) in Tertiary schools?
Offer a very short reply. 5.46. 